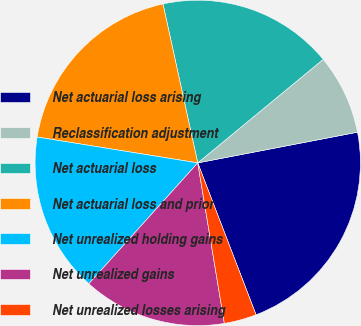<chart> <loc_0><loc_0><loc_500><loc_500><pie_chart><fcel>Net actuarial loss arising<fcel>Reclassification adjustment<fcel>Net actuarial loss<fcel>Net actuarial loss and prior<fcel>Net unrealized holding gains<fcel>Net unrealized gains<fcel>Net unrealized losses arising<nl><fcel>22.19%<fcel>7.96%<fcel>17.45%<fcel>19.03%<fcel>15.87%<fcel>14.29%<fcel>3.22%<nl></chart> 